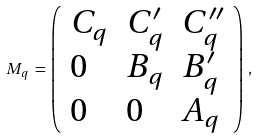Convert formula to latex. <formula><loc_0><loc_0><loc_500><loc_500>M _ { q } \, = \, \left ( \begin{array} { l l l } { { C _ { q } } } & { { C _ { q } ^ { \prime } } } & { { C _ { q } ^ { \prime \prime } } } \\ { 0 } & { { B _ { q } } } & { { B _ { q } ^ { \prime } } } \\ { 0 } & { 0 } & { { A _ { q } } } \end{array} \right ) \, ,</formula> 